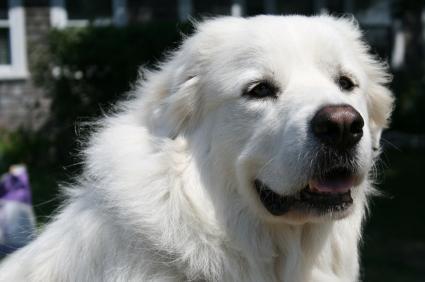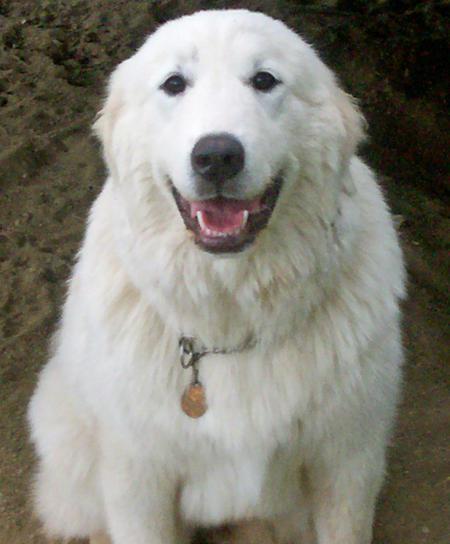The first image is the image on the left, the second image is the image on the right. Considering the images on both sides, is "The dog on the right image is of a young puppy." valid? Answer yes or no. No. 